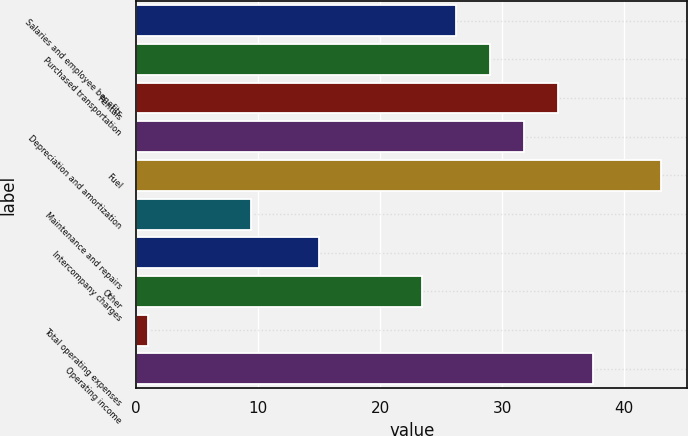Convert chart. <chart><loc_0><loc_0><loc_500><loc_500><bar_chart><fcel>Salaries and employee benefits<fcel>Purchased transportation<fcel>Rentals<fcel>Depreciation and amortization<fcel>Fuel<fcel>Maintenance and repairs<fcel>Intercompany charges<fcel>Other<fcel>Total operating expenses<fcel>Operating income<nl><fcel>26.2<fcel>29<fcel>34.6<fcel>31.8<fcel>43<fcel>9.4<fcel>15<fcel>23.4<fcel>1<fcel>37.4<nl></chart> 